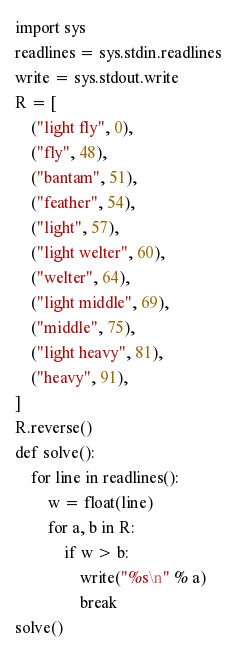<code> <loc_0><loc_0><loc_500><loc_500><_Python_>import sys
readlines = sys.stdin.readlines
write = sys.stdout.write
R = [
    ("light fly", 0),
    ("fly", 48),
    ("bantam", 51),
    ("feather", 54),
    ("light", 57),
    ("light welter", 60),
    ("welter", 64),
    ("light middle", 69),
    ("middle", 75),
    ("light heavy", 81),
    ("heavy", 91),
]
R.reverse()
def solve():
    for line in readlines():
        w = float(line)
        for a, b in R:
            if w > b:
                write("%s\n" % a)
                break
solve()

</code> 